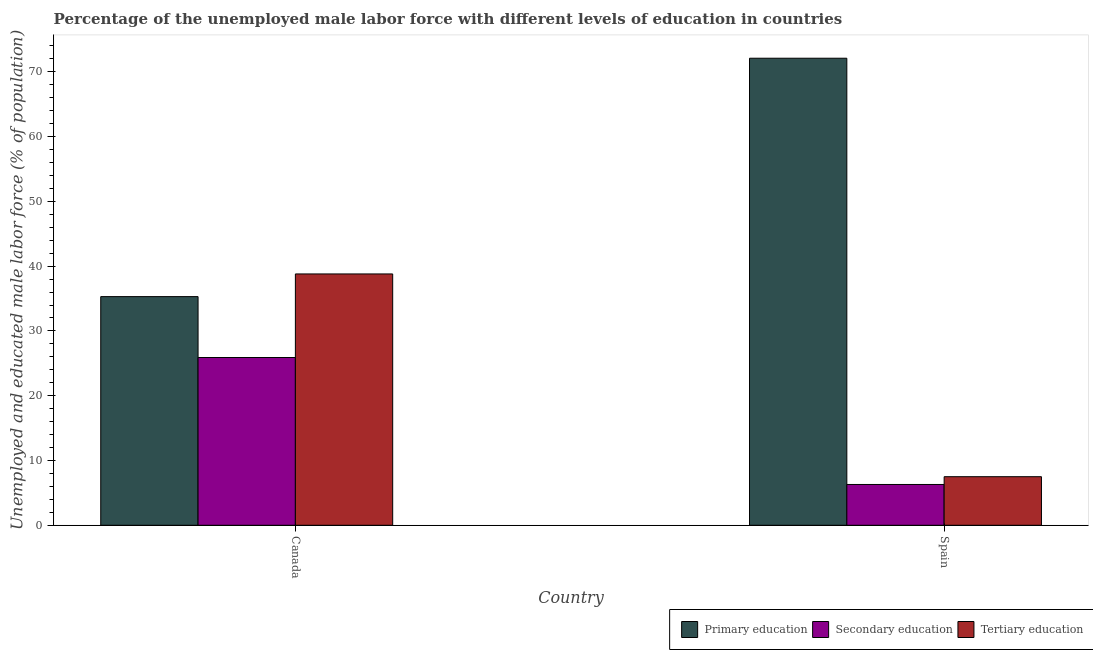Are the number of bars per tick equal to the number of legend labels?
Give a very brief answer. Yes. Are the number of bars on each tick of the X-axis equal?
Offer a very short reply. Yes. How many bars are there on the 1st tick from the right?
Offer a terse response. 3. What is the label of the 1st group of bars from the left?
Provide a succinct answer. Canada. In how many cases, is the number of bars for a given country not equal to the number of legend labels?
Give a very brief answer. 0. What is the percentage of male labor force who received primary education in Canada?
Provide a succinct answer. 35.3. Across all countries, what is the maximum percentage of male labor force who received primary education?
Offer a terse response. 72.1. Across all countries, what is the minimum percentage of male labor force who received tertiary education?
Ensure brevity in your answer.  7.5. In which country was the percentage of male labor force who received primary education minimum?
Your answer should be very brief. Canada. What is the total percentage of male labor force who received tertiary education in the graph?
Provide a short and direct response. 46.3. What is the difference between the percentage of male labor force who received tertiary education in Canada and that in Spain?
Keep it short and to the point. 31.3. What is the difference between the percentage of male labor force who received tertiary education in Canada and the percentage of male labor force who received secondary education in Spain?
Give a very brief answer. 32.5. What is the average percentage of male labor force who received tertiary education per country?
Provide a short and direct response. 23.15. What is the difference between the percentage of male labor force who received primary education and percentage of male labor force who received secondary education in Spain?
Make the answer very short. 65.8. In how many countries, is the percentage of male labor force who received tertiary education greater than 44 %?
Offer a terse response. 0. What is the ratio of the percentage of male labor force who received secondary education in Canada to that in Spain?
Give a very brief answer. 4.11. What does the 1st bar from the right in Canada represents?
Your response must be concise. Tertiary education. How many bars are there?
Ensure brevity in your answer.  6. What is the difference between two consecutive major ticks on the Y-axis?
Ensure brevity in your answer.  10. Are the values on the major ticks of Y-axis written in scientific E-notation?
Provide a short and direct response. No. Does the graph contain any zero values?
Your response must be concise. No. Where does the legend appear in the graph?
Make the answer very short. Bottom right. How many legend labels are there?
Provide a short and direct response. 3. How are the legend labels stacked?
Offer a terse response. Horizontal. What is the title of the graph?
Provide a short and direct response. Percentage of the unemployed male labor force with different levels of education in countries. What is the label or title of the X-axis?
Offer a very short reply. Country. What is the label or title of the Y-axis?
Ensure brevity in your answer.  Unemployed and educated male labor force (% of population). What is the Unemployed and educated male labor force (% of population) in Primary education in Canada?
Provide a short and direct response. 35.3. What is the Unemployed and educated male labor force (% of population) in Secondary education in Canada?
Provide a short and direct response. 25.9. What is the Unemployed and educated male labor force (% of population) of Tertiary education in Canada?
Offer a very short reply. 38.8. What is the Unemployed and educated male labor force (% of population) in Primary education in Spain?
Offer a very short reply. 72.1. What is the Unemployed and educated male labor force (% of population) in Secondary education in Spain?
Give a very brief answer. 6.3. What is the Unemployed and educated male labor force (% of population) in Tertiary education in Spain?
Provide a short and direct response. 7.5. Across all countries, what is the maximum Unemployed and educated male labor force (% of population) of Primary education?
Your answer should be compact. 72.1. Across all countries, what is the maximum Unemployed and educated male labor force (% of population) in Secondary education?
Keep it short and to the point. 25.9. Across all countries, what is the maximum Unemployed and educated male labor force (% of population) of Tertiary education?
Provide a short and direct response. 38.8. Across all countries, what is the minimum Unemployed and educated male labor force (% of population) of Primary education?
Offer a terse response. 35.3. Across all countries, what is the minimum Unemployed and educated male labor force (% of population) in Secondary education?
Your answer should be very brief. 6.3. Across all countries, what is the minimum Unemployed and educated male labor force (% of population) of Tertiary education?
Offer a terse response. 7.5. What is the total Unemployed and educated male labor force (% of population) in Primary education in the graph?
Your answer should be compact. 107.4. What is the total Unemployed and educated male labor force (% of population) of Secondary education in the graph?
Provide a short and direct response. 32.2. What is the total Unemployed and educated male labor force (% of population) of Tertiary education in the graph?
Offer a very short reply. 46.3. What is the difference between the Unemployed and educated male labor force (% of population) of Primary education in Canada and that in Spain?
Offer a very short reply. -36.8. What is the difference between the Unemployed and educated male labor force (% of population) in Secondary education in Canada and that in Spain?
Give a very brief answer. 19.6. What is the difference between the Unemployed and educated male labor force (% of population) in Tertiary education in Canada and that in Spain?
Give a very brief answer. 31.3. What is the difference between the Unemployed and educated male labor force (% of population) in Primary education in Canada and the Unemployed and educated male labor force (% of population) in Tertiary education in Spain?
Give a very brief answer. 27.8. What is the average Unemployed and educated male labor force (% of population) in Primary education per country?
Provide a succinct answer. 53.7. What is the average Unemployed and educated male labor force (% of population) in Tertiary education per country?
Offer a very short reply. 23.15. What is the difference between the Unemployed and educated male labor force (% of population) in Primary education and Unemployed and educated male labor force (% of population) in Secondary education in Canada?
Make the answer very short. 9.4. What is the difference between the Unemployed and educated male labor force (% of population) in Secondary education and Unemployed and educated male labor force (% of population) in Tertiary education in Canada?
Ensure brevity in your answer.  -12.9. What is the difference between the Unemployed and educated male labor force (% of population) in Primary education and Unemployed and educated male labor force (% of population) in Secondary education in Spain?
Ensure brevity in your answer.  65.8. What is the difference between the Unemployed and educated male labor force (% of population) of Primary education and Unemployed and educated male labor force (% of population) of Tertiary education in Spain?
Provide a short and direct response. 64.6. What is the difference between the Unemployed and educated male labor force (% of population) in Secondary education and Unemployed and educated male labor force (% of population) in Tertiary education in Spain?
Offer a very short reply. -1.2. What is the ratio of the Unemployed and educated male labor force (% of population) in Primary education in Canada to that in Spain?
Your answer should be very brief. 0.49. What is the ratio of the Unemployed and educated male labor force (% of population) in Secondary education in Canada to that in Spain?
Keep it short and to the point. 4.11. What is the ratio of the Unemployed and educated male labor force (% of population) of Tertiary education in Canada to that in Spain?
Ensure brevity in your answer.  5.17. What is the difference between the highest and the second highest Unemployed and educated male labor force (% of population) of Primary education?
Ensure brevity in your answer.  36.8. What is the difference between the highest and the second highest Unemployed and educated male labor force (% of population) of Secondary education?
Make the answer very short. 19.6. What is the difference between the highest and the second highest Unemployed and educated male labor force (% of population) of Tertiary education?
Your answer should be compact. 31.3. What is the difference between the highest and the lowest Unemployed and educated male labor force (% of population) in Primary education?
Offer a terse response. 36.8. What is the difference between the highest and the lowest Unemployed and educated male labor force (% of population) of Secondary education?
Provide a succinct answer. 19.6. What is the difference between the highest and the lowest Unemployed and educated male labor force (% of population) of Tertiary education?
Offer a terse response. 31.3. 